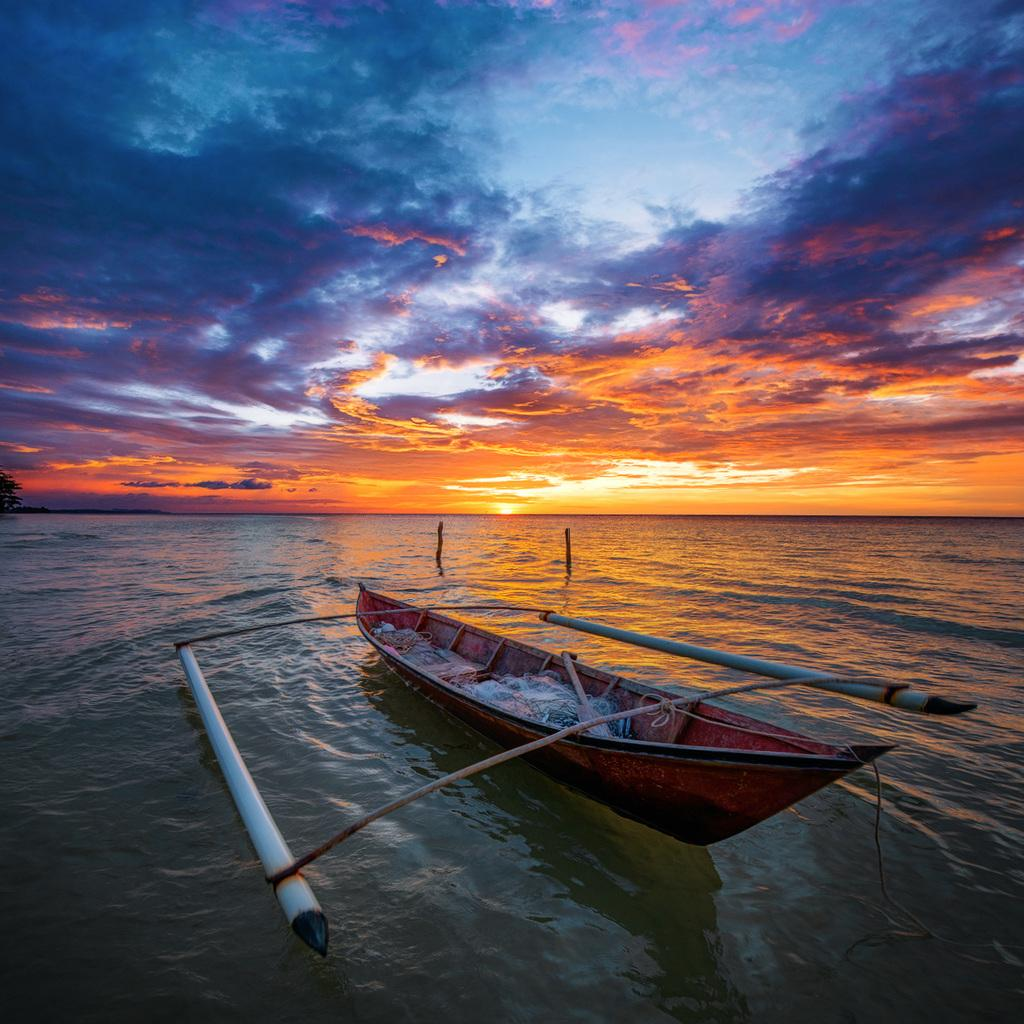What body of water is present at the bottom of the image? There is a river at the bottom of the image. What is in the river? There is a boat in the river. Are there any other objects in the river besides the boat? Yes, there are two poles in the river. What is visible at the top of the image? The sky is visible at the top of the image. What type of food is being argued about in the image? There is no food or argument present in the image; it features a river, a boat, and two poles. In which direction is the river flowing in the image? The image does not provide information about the direction of the river flow. 